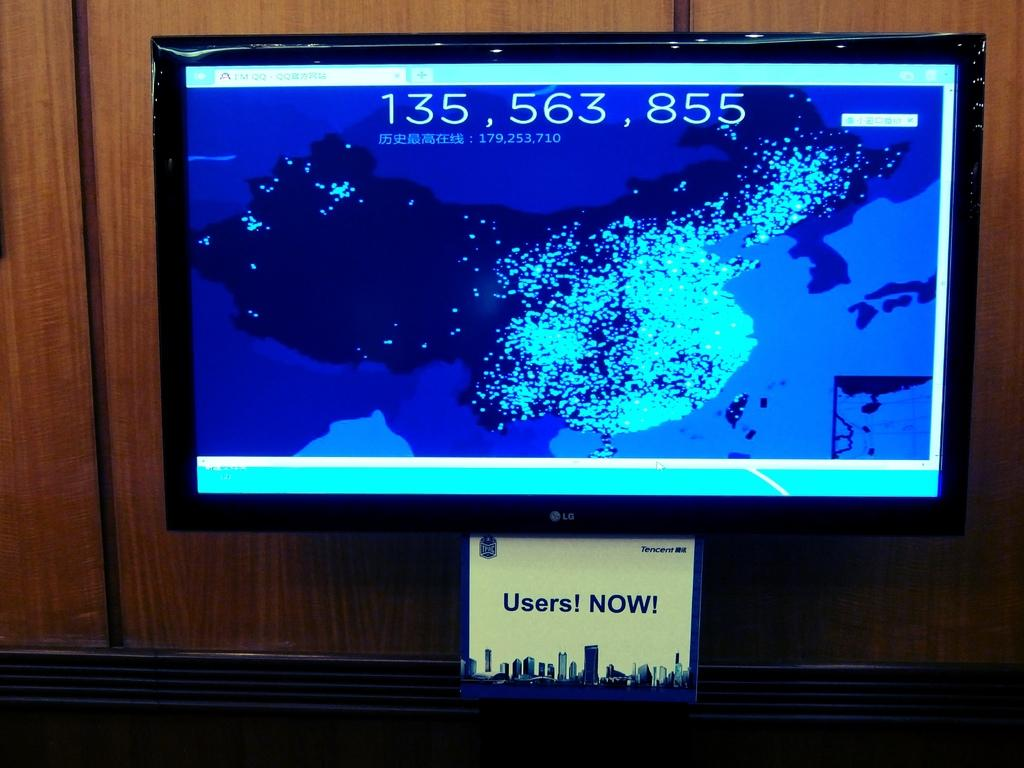<image>
Offer a succinct explanation of the picture presented. A screen shows the numbers 135, 563, 855 at the top of a map and a sign underneath says Users! NOW! 